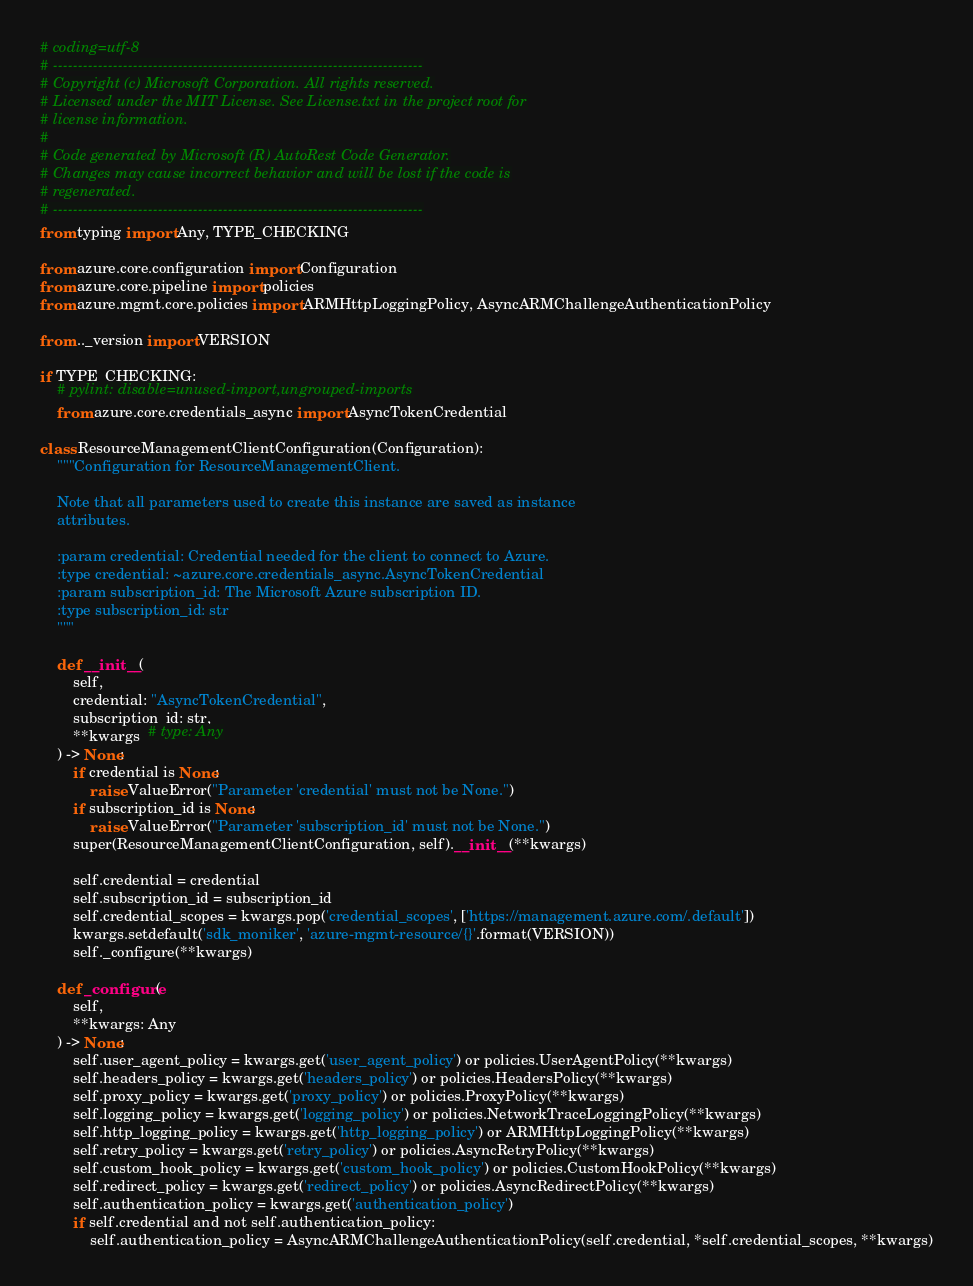Convert code to text. <code><loc_0><loc_0><loc_500><loc_500><_Python_># coding=utf-8
# --------------------------------------------------------------------------
# Copyright (c) Microsoft Corporation. All rights reserved.
# Licensed under the MIT License. See License.txt in the project root for
# license information.
#
# Code generated by Microsoft (R) AutoRest Code Generator.
# Changes may cause incorrect behavior and will be lost if the code is
# regenerated.
# --------------------------------------------------------------------------
from typing import Any, TYPE_CHECKING

from azure.core.configuration import Configuration
from azure.core.pipeline import policies
from azure.mgmt.core.policies import ARMHttpLoggingPolicy, AsyncARMChallengeAuthenticationPolicy

from .._version import VERSION

if TYPE_CHECKING:
    # pylint: disable=unused-import,ungrouped-imports
    from azure.core.credentials_async import AsyncTokenCredential

class ResourceManagementClientConfiguration(Configuration):
    """Configuration for ResourceManagementClient.

    Note that all parameters used to create this instance are saved as instance
    attributes.

    :param credential: Credential needed for the client to connect to Azure.
    :type credential: ~azure.core.credentials_async.AsyncTokenCredential
    :param subscription_id: The Microsoft Azure subscription ID.
    :type subscription_id: str
    """

    def __init__(
        self,
        credential: "AsyncTokenCredential",
        subscription_id: str,
        **kwargs  # type: Any
    ) -> None:
        if credential is None:
            raise ValueError("Parameter 'credential' must not be None.")
        if subscription_id is None:
            raise ValueError("Parameter 'subscription_id' must not be None.")
        super(ResourceManagementClientConfiguration, self).__init__(**kwargs)

        self.credential = credential
        self.subscription_id = subscription_id
        self.credential_scopes = kwargs.pop('credential_scopes', ['https://management.azure.com/.default'])
        kwargs.setdefault('sdk_moniker', 'azure-mgmt-resource/{}'.format(VERSION))
        self._configure(**kwargs)

    def _configure(
        self,
        **kwargs: Any
    ) -> None:
        self.user_agent_policy = kwargs.get('user_agent_policy') or policies.UserAgentPolicy(**kwargs)
        self.headers_policy = kwargs.get('headers_policy') or policies.HeadersPolicy(**kwargs)
        self.proxy_policy = kwargs.get('proxy_policy') or policies.ProxyPolicy(**kwargs)
        self.logging_policy = kwargs.get('logging_policy') or policies.NetworkTraceLoggingPolicy(**kwargs)
        self.http_logging_policy = kwargs.get('http_logging_policy') or ARMHttpLoggingPolicy(**kwargs)
        self.retry_policy = kwargs.get('retry_policy') or policies.AsyncRetryPolicy(**kwargs)
        self.custom_hook_policy = kwargs.get('custom_hook_policy') or policies.CustomHookPolicy(**kwargs)
        self.redirect_policy = kwargs.get('redirect_policy') or policies.AsyncRedirectPolicy(**kwargs)
        self.authentication_policy = kwargs.get('authentication_policy')
        if self.credential and not self.authentication_policy:
            self.authentication_policy = AsyncARMChallengeAuthenticationPolicy(self.credential, *self.credential_scopes, **kwargs)
</code> 